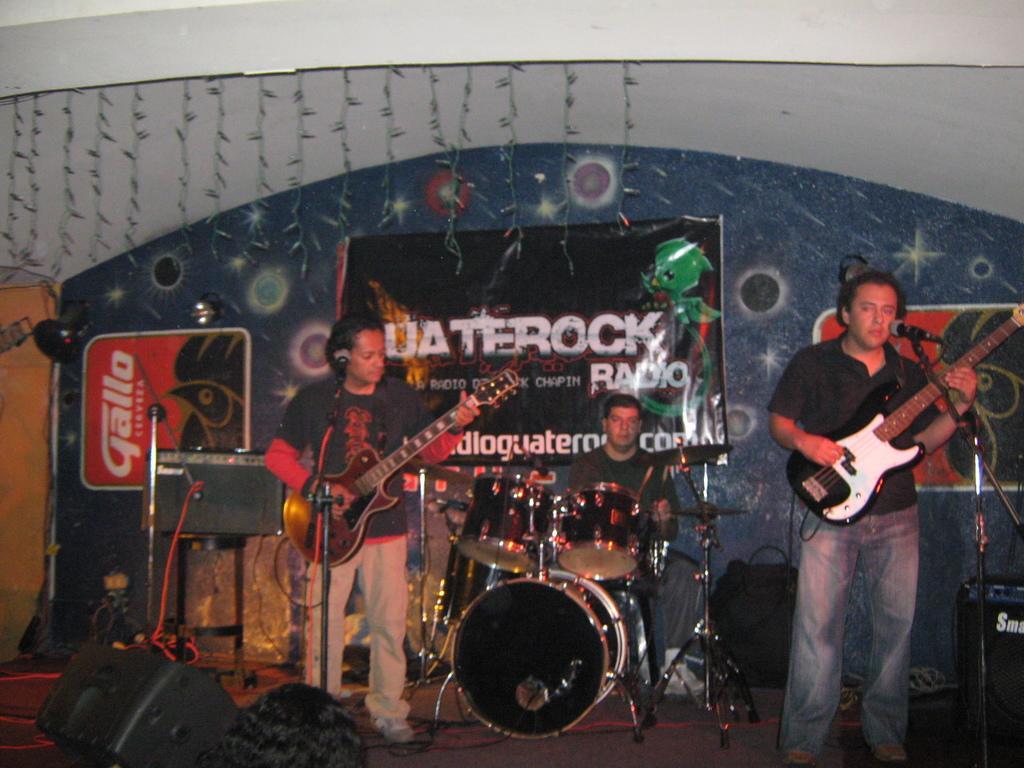Can you describe this image briefly? This is a image inside of a room and there are the three persons holding a guitar on their hands and playing a music. And on the right side a person standing and wearing a black color shirt in front of him there is a mike and there are drugs kept on the floor in the middle 